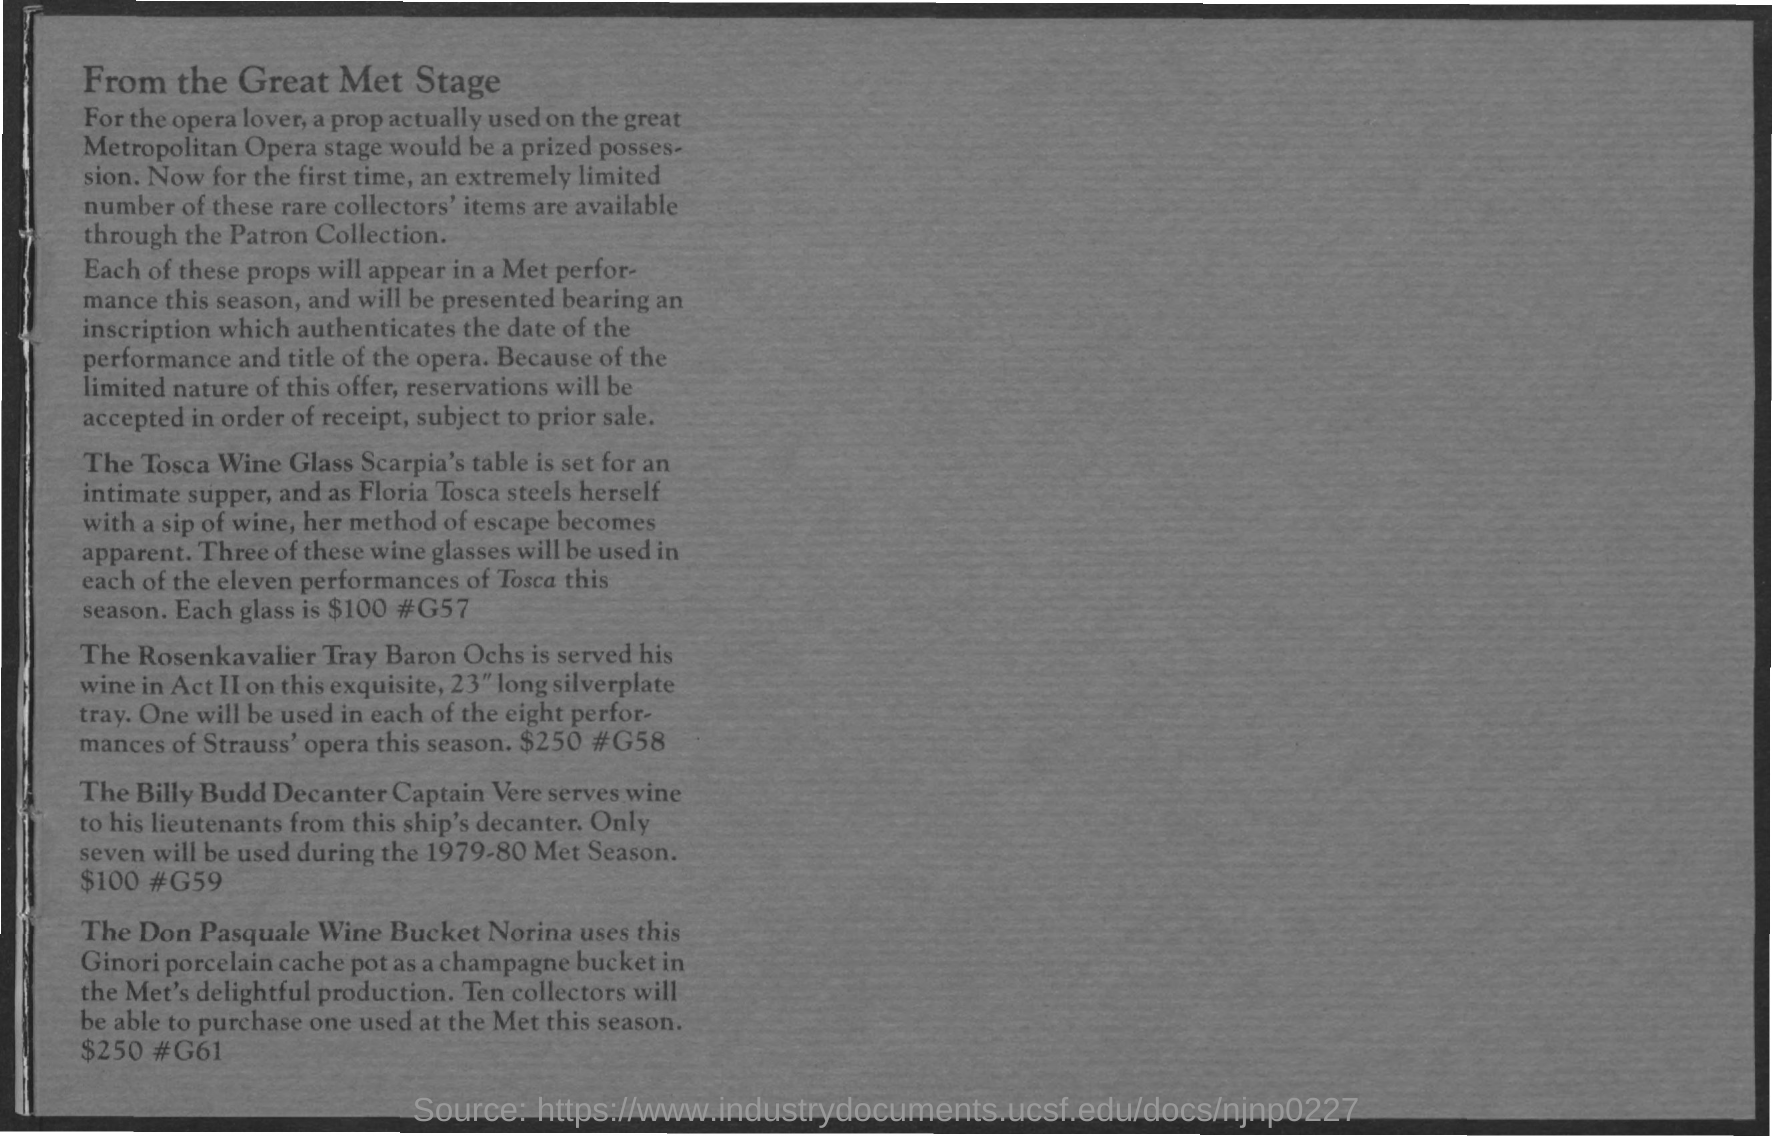What is the first title in the document?
Provide a short and direct response. FROM THE GREAT MET STAGE. 